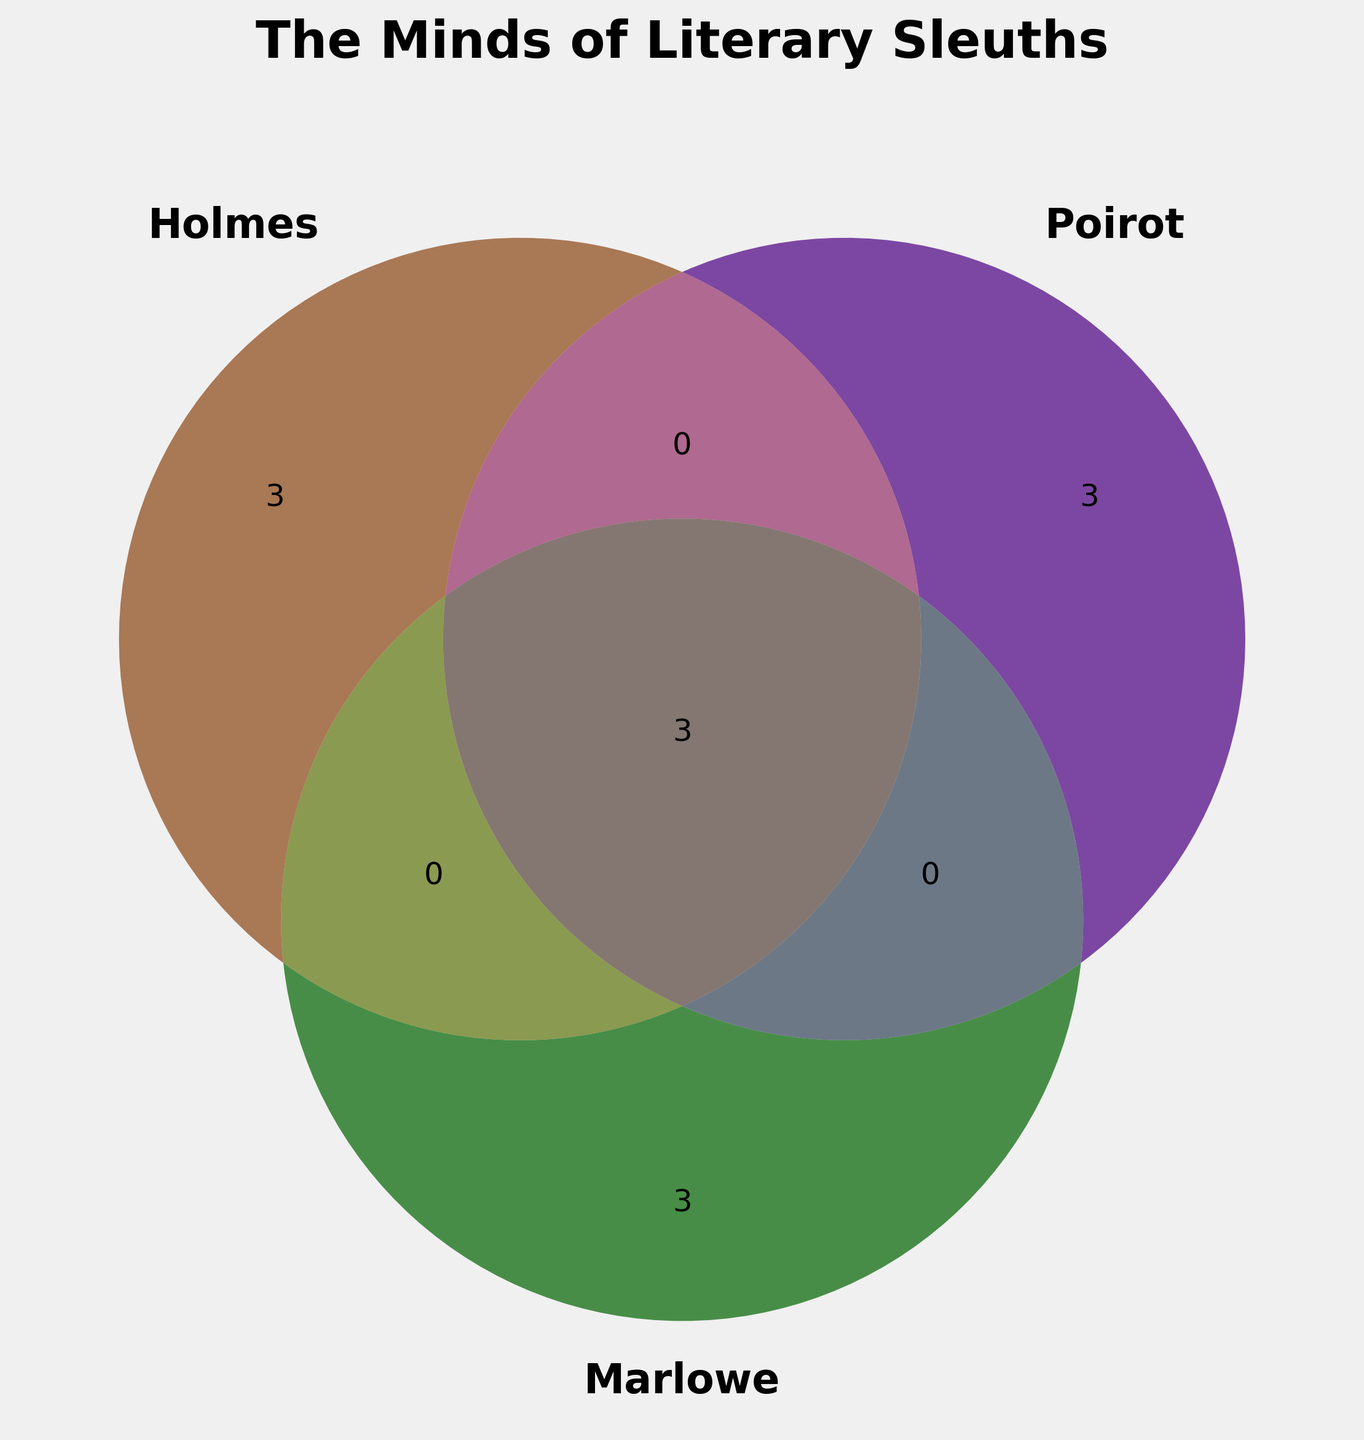What's the title of the figure? The title of the figure is clearly displayed at the top and reads "The Minds of Literary Sleuths."
Answer: The Minds of Literary Sleuths Which detective shares the most characteristics with Sherlock Holmes? By examining the overlapping areas in the Venn diagram, the largest intersection involving Sherlock Holmes is with the other two detectives, indicating he shares many traits with both Poirot and Marlowe. However, to specifically determine which one shares the most directly, we need to consider the areas where only Holmes overlaps with others.
Answer: Both Poirot and Marlowe (equal share) What characteristic is unique to Philip Marlowe among the three detectives? From the Venn diagram, only the section representing Marlowe without overlap indicates unique traits. By examining this area, we can see "Tough-talking," "Cynical," and "Moral code" are listed.
Answer: Tough-talking, Cynical, Moral code How many characteristics are shared by all three detectives? Look at the center area where all three circles overlap. The characteristic(s) listed in this intersection are shared by all three.
Answer: 3 (Brilliant, Outsider mentality, Obsessive) Which detective is noted for having 'Logical deduction' as a trait? The individual section of the Venn diagram for Sherlock Holmes lists 'Logical deduction' as one of his unique traits.
Answer: Sherlock Holmes How many shared traits are common between Holmes and Poirot but not Marlowe? Examine the area where only the circles for Holmes and Poirot overlap without including Marlowe.
Answer: 0 What traits are shared by Holmes and Marlowe but not Poirot? Check the overlapping section of the Venn diagram between Holmes and Marlowe, excluding Poirot.
Answer: 0 Which color represents Hercule Poirot in the Venn diagram? By referring to the color legend in the Venn diagram, Hercule Poirot is indicated by the color indigo.
Answer: Indigo Which detective has 'Vanity' as a characteristic? Look at the section of the Venn diagram specific to Hercule Poirot to find 'Vanity' listed as one of his traits.
Answer: Hercule Poirot What is the commonality between Holmes and Poirot that Marlowe doesn't share in their individual traits? Examine the intersection between Holmes and Poirot for shared traits, specifically those not shared with Marlowe. Cross-reference to confirm no such commonality excluding Marlowe.
Answer: None 